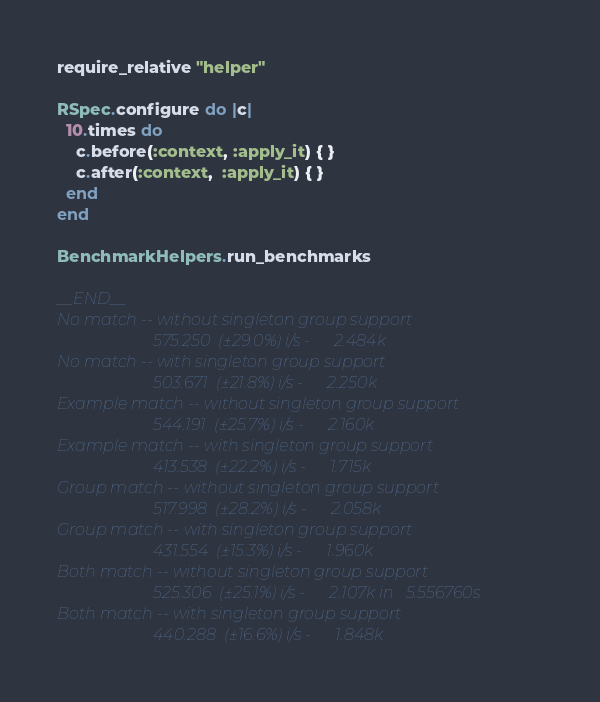Convert code to text. <code><loc_0><loc_0><loc_500><loc_500><_Ruby_>require_relative "helper"

RSpec.configure do |c|
  10.times do
    c.before(:context, :apply_it) { }
    c.after(:context,  :apply_it) { }
  end
end

BenchmarkHelpers.run_benchmarks

__END__
No match -- without singleton group support
                        575.250  (±29.0%) i/s -      2.484k
No match -- with singleton group support
                        503.671  (±21.8%) i/s -      2.250k
Example match -- without singleton group support
                        544.191  (±25.7%) i/s -      2.160k
Example match -- with singleton group support
                        413.538  (±22.2%) i/s -      1.715k
Group match -- without singleton group support
                        517.998  (±28.2%) i/s -      2.058k
Group match -- with singleton group support
                        431.554  (±15.3%) i/s -      1.960k
Both match -- without singleton group support
                        525.306  (±25.1%) i/s -      2.107k in   5.556760s
Both match -- with singleton group support
                        440.288  (±16.6%) i/s -      1.848k
</code> 